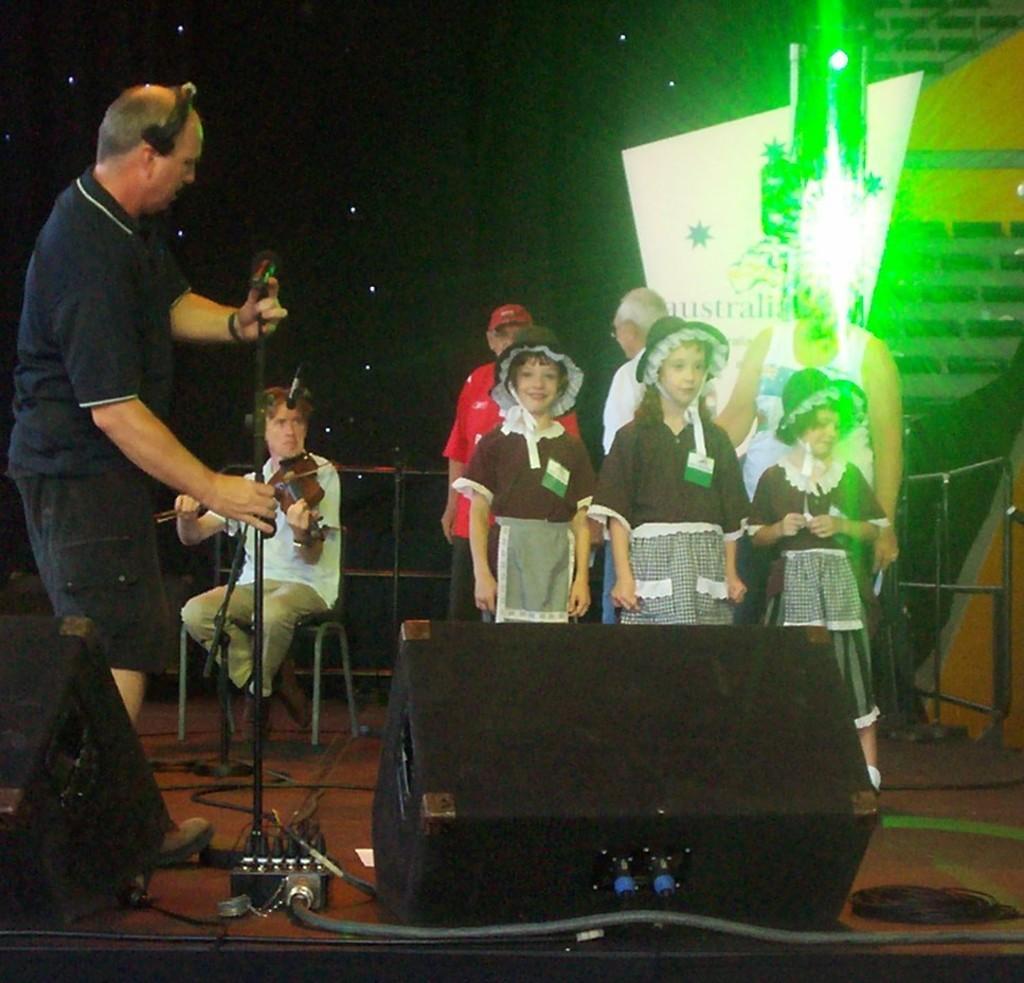How would you summarize this image in a sentence or two? In this image we can see three kids wearing brown color dress. Behind them there are three people standing. To the left side of the image there is a person wearing headphones and holding a mic stand. There is a person sitting on a chair and playing a violin. In the background of the image there is a screen. At the bottom of the image there is floor. There are speakers. 